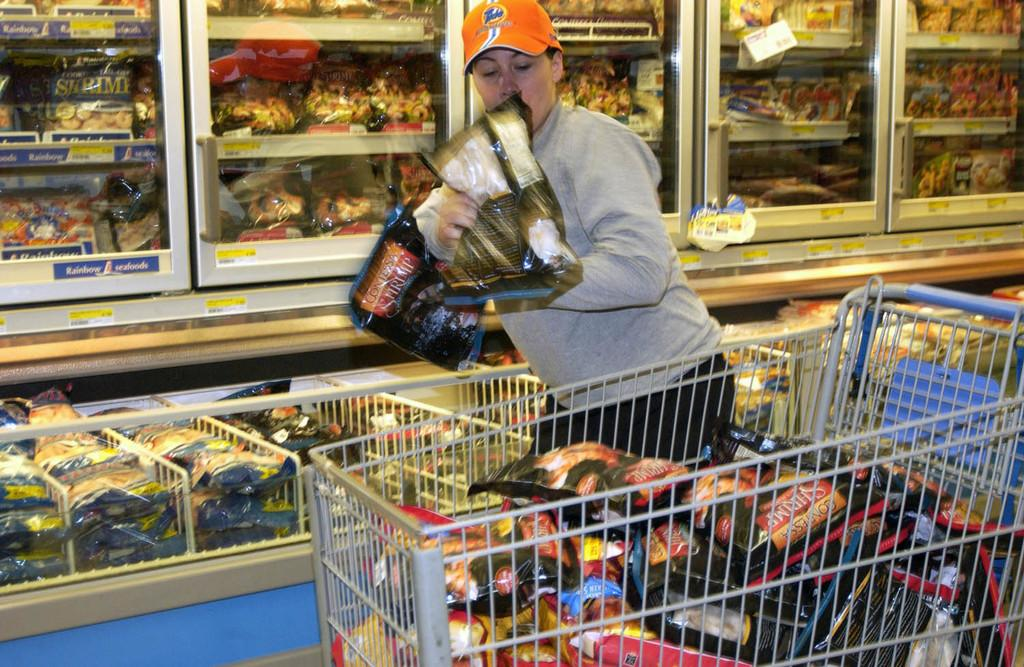<image>
Describe the image concisely. A man in a supermarket aisle with the word seafoods visible 